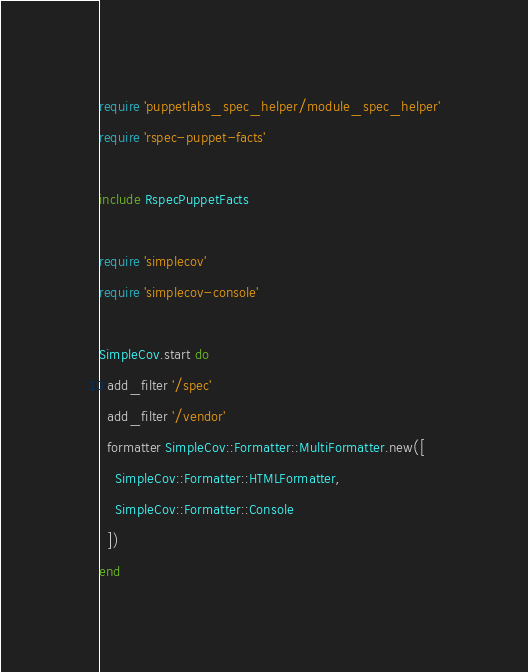<code> <loc_0><loc_0><loc_500><loc_500><_Ruby_>require 'puppetlabs_spec_helper/module_spec_helper'
require 'rspec-puppet-facts'

include RspecPuppetFacts

require 'simplecov'
require 'simplecov-console'

SimpleCov.start do
  add_filter '/spec'
  add_filter '/vendor'
  formatter SimpleCov::Formatter::MultiFormatter.new([
    SimpleCov::Formatter::HTMLFormatter,
    SimpleCov::Formatter::Console
  ])
end
</code> 